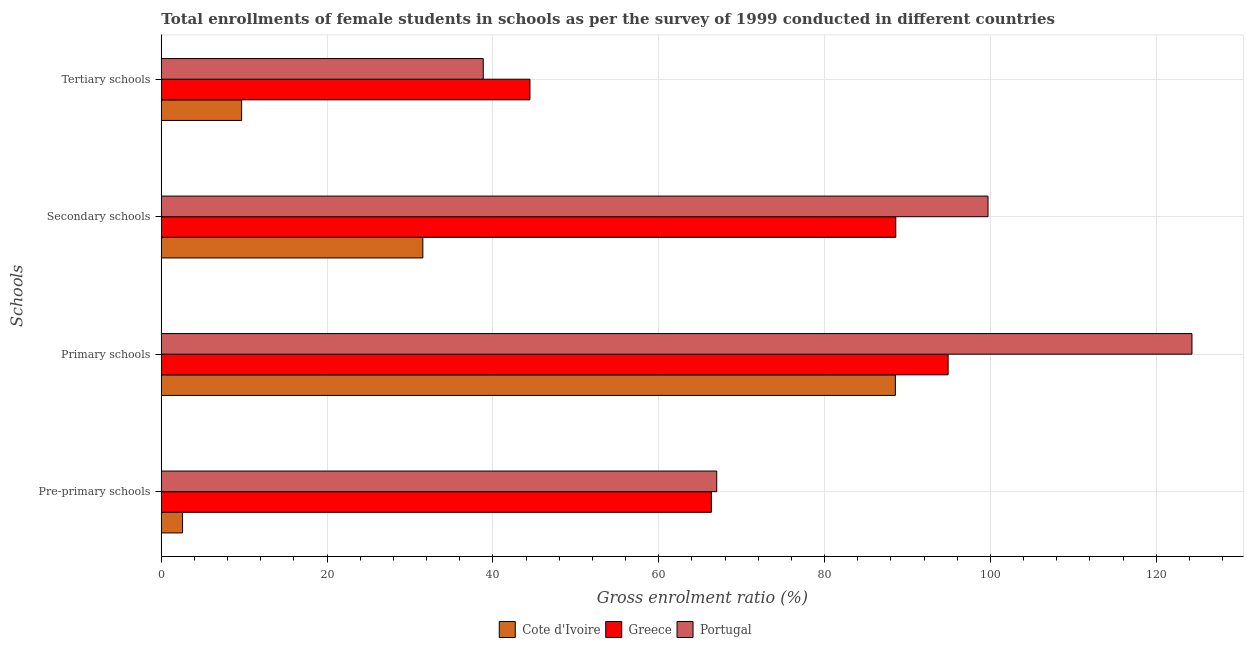How many groups of bars are there?
Your answer should be very brief. 4. Are the number of bars per tick equal to the number of legend labels?
Make the answer very short. Yes. How many bars are there on the 3rd tick from the top?
Make the answer very short. 3. What is the label of the 1st group of bars from the top?
Your response must be concise. Tertiary schools. What is the gross enrolment ratio(female) in pre-primary schools in Greece?
Your answer should be compact. 66.35. Across all countries, what is the maximum gross enrolment ratio(female) in tertiary schools?
Make the answer very short. 44.46. Across all countries, what is the minimum gross enrolment ratio(female) in primary schools?
Give a very brief answer. 88.54. In which country was the gross enrolment ratio(female) in pre-primary schools minimum?
Offer a terse response. Cote d'Ivoire. What is the total gross enrolment ratio(female) in tertiary schools in the graph?
Provide a succinct answer. 92.98. What is the difference between the gross enrolment ratio(female) in secondary schools in Portugal and that in Greece?
Your response must be concise. 11.12. What is the difference between the gross enrolment ratio(female) in pre-primary schools in Portugal and the gross enrolment ratio(female) in tertiary schools in Greece?
Give a very brief answer. 22.53. What is the average gross enrolment ratio(female) in tertiary schools per country?
Offer a very short reply. 30.99. What is the difference between the gross enrolment ratio(female) in pre-primary schools and gross enrolment ratio(female) in secondary schools in Portugal?
Keep it short and to the point. -32.72. What is the ratio of the gross enrolment ratio(female) in tertiary schools in Portugal to that in Cote d'Ivoire?
Make the answer very short. 4.01. What is the difference between the highest and the second highest gross enrolment ratio(female) in primary schools?
Give a very brief answer. 29.41. What is the difference between the highest and the lowest gross enrolment ratio(female) in tertiary schools?
Provide a short and direct response. 34.78. In how many countries, is the gross enrolment ratio(female) in secondary schools greater than the average gross enrolment ratio(female) in secondary schools taken over all countries?
Offer a very short reply. 2. Is it the case that in every country, the sum of the gross enrolment ratio(female) in pre-primary schools and gross enrolment ratio(female) in tertiary schools is greater than the sum of gross enrolment ratio(female) in primary schools and gross enrolment ratio(female) in secondary schools?
Your answer should be very brief. No. What does the 2nd bar from the bottom in Tertiary schools represents?
Your answer should be very brief. Greece. Is it the case that in every country, the sum of the gross enrolment ratio(female) in pre-primary schools and gross enrolment ratio(female) in primary schools is greater than the gross enrolment ratio(female) in secondary schools?
Provide a succinct answer. Yes. How many countries are there in the graph?
Your answer should be compact. 3. What is the difference between two consecutive major ticks on the X-axis?
Provide a succinct answer. 20. Where does the legend appear in the graph?
Offer a very short reply. Bottom center. How many legend labels are there?
Keep it short and to the point. 3. How are the legend labels stacked?
Ensure brevity in your answer.  Horizontal. What is the title of the graph?
Offer a terse response. Total enrollments of female students in schools as per the survey of 1999 conducted in different countries. Does "Guinea" appear as one of the legend labels in the graph?
Provide a short and direct response. No. What is the label or title of the Y-axis?
Offer a very short reply. Schools. What is the Gross enrolment ratio (%) in Cote d'Ivoire in Pre-primary schools?
Ensure brevity in your answer.  2.56. What is the Gross enrolment ratio (%) in Greece in Pre-primary schools?
Your response must be concise. 66.35. What is the Gross enrolment ratio (%) of Portugal in Pre-primary schools?
Keep it short and to the point. 66.99. What is the Gross enrolment ratio (%) of Cote d'Ivoire in Primary schools?
Make the answer very short. 88.54. What is the Gross enrolment ratio (%) of Greece in Primary schools?
Your answer should be compact. 94.9. What is the Gross enrolment ratio (%) of Portugal in Primary schools?
Offer a very short reply. 124.32. What is the Gross enrolment ratio (%) of Cote d'Ivoire in Secondary schools?
Ensure brevity in your answer.  31.54. What is the Gross enrolment ratio (%) of Greece in Secondary schools?
Provide a succinct answer. 88.59. What is the Gross enrolment ratio (%) of Portugal in Secondary schools?
Provide a short and direct response. 99.72. What is the Gross enrolment ratio (%) in Cote d'Ivoire in Tertiary schools?
Provide a succinct answer. 9.69. What is the Gross enrolment ratio (%) of Greece in Tertiary schools?
Keep it short and to the point. 44.46. What is the Gross enrolment ratio (%) in Portugal in Tertiary schools?
Provide a short and direct response. 38.83. Across all Schools, what is the maximum Gross enrolment ratio (%) of Cote d'Ivoire?
Ensure brevity in your answer.  88.54. Across all Schools, what is the maximum Gross enrolment ratio (%) of Greece?
Your answer should be very brief. 94.9. Across all Schools, what is the maximum Gross enrolment ratio (%) of Portugal?
Make the answer very short. 124.32. Across all Schools, what is the minimum Gross enrolment ratio (%) in Cote d'Ivoire?
Provide a short and direct response. 2.56. Across all Schools, what is the minimum Gross enrolment ratio (%) in Greece?
Give a very brief answer. 44.46. Across all Schools, what is the minimum Gross enrolment ratio (%) in Portugal?
Your answer should be very brief. 38.83. What is the total Gross enrolment ratio (%) of Cote d'Ivoire in the graph?
Offer a terse response. 132.33. What is the total Gross enrolment ratio (%) of Greece in the graph?
Give a very brief answer. 294.31. What is the total Gross enrolment ratio (%) in Portugal in the graph?
Offer a very short reply. 329.86. What is the difference between the Gross enrolment ratio (%) of Cote d'Ivoire in Pre-primary schools and that in Primary schools?
Offer a terse response. -85.98. What is the difference between the Gross enrolment ratio (%) of Greece in Pre-primary schools and that in Primary schools?
Your answer should be very brief. -28.56. What is the difference between the Gross enrolment ratio (%) of Portugal in Pre-primary schools and that in Primary schools?
Provide a succinct answer. -57.32. What is the difference between the Gross enrolment ratio (%) of Cote d'Ivoire in Pre-primary schools and that in Secondary schools?
Give a very brief answer. -28.98. What is the difference between the Gross enrolment ratio (%) in Greece in Pre-primary schools and that in Secondary schools?
Offer a terse response. -22.24. What is the difference between the Gross enrolment ratio (%) in Portugal in Pre-primary schools and that in Secondary schools?
Your response must be concise. -32.72. What is the difference between the Gross enrolment ratio (%) in Cote d'Ivoire in Pre-primary schools and that in Tertiary schools?
Your response must be concise. -7.13. What is the difference between the Gross enrolment ratio (%) in Greece in Pre-primary schools and that in Tertiary schools?
Offer a terse response. 21.88. What is the difference between the Gross enrolment ratio (%) of Portugal in Pre-primary schools and that in Tertiary schools?
Your response must be concise. 28.16. What is the difference between the Gross enrolment ratio (%) of Cote d'Ivoire in Primary schools and that in Secondary schools?
Offer a terse response. 57. What is the difference between the Gross enrolment ratio (%) of Greece in Primary schools and that in Secondary schools?
Give a very brief answer. 6.31. What is the difference between the Gross enrolment ratio (%) of Portugal in Primary schools and that in Secondary schools?
Offer a terse response. 24.6. What is the difference between the Gross enrolment ratio (%) in Cote d'Ivoire in Primary schools and that in Tertiary schools?
Keep it short and to the point. 78.85. What is the difference between the Gross enrolment ratio (%) in Greece in Primary schools and that in Tertiary schools?
Provide a succinct answer. 50.44. What is the difference between the Gross enrolment ratio (%) in Portugal in Primary schools and that in Tertiary schools?
Provide a succinct answer. 85.48. What is the difference between the Gross enrolment ratio (%) of Cote d'Ivoire in Secondary schools and that in Tertiary schools?
Offer a terse response. 21.86. What is the difference between the Gross enrolment ratio (%) of Greece in Secondary schools and that in Tertiary schools?
Provide a short and direct response. 44.13. What is the difference between the Gross enrolment ratio (%) in Portugal in Secondary schools and that in Tertiary schools?
Keep it short and to the point. 60.88. What is the difference between the Gross enrolment ratio (%) of Cote d'Ivoire in Pre-primary schools and the Gross enrolment ratio (%) of Greece in Primary schools?
Keep it short and to the point. -92.34. What is the difference between the Gross enrolment ratio (%) of Cote d'Ivoire in Pre-primary schools and the Gross enrolment ratio (%) of Portugal in Primary schools?
Keep it short and to the point. -121.76. What is the difference between the Gross enrolment ratio (%) in Greece in Pre-primary schools and the Gross enrolment ratio (%) in Portugal in Primary schools?
Give a very brief answer. -57.97. What is the difference between the Gross enrolment ratio (%) of Cote d'Ivoire in Pre-primary schools and the Gross enrolment ratio (%) of Greece in Secondary schools?
Provide a succinct answer. -86.03. What is the difference between the Gross enrolment ratio (%) in Cote d'Ivoire in Pre-primary schools and the Gross enrolment ratio (%) in Portugal in Secondary schools?
Keep it short and to the point. -97.15. What is the difference between the Gross enrolment ratio (%) in Greece in Pre-primary schools and the Gross enrolment ratio (%) in Portugal in Secondary schools?
Your answer should be compact. -33.37. What is the difference between the Gross enrolment ratio (%) in Cote d'Ivoire in Pre-primary schools and the Gross enrolment ratio (%) in Greece in Tertiary schools?
Give a very brief answer. -41.9. What is the difference between the Gross enrolment ratio (%) of Cote d'Ivoire in Pre-primary schools and the Gross enrolment ratio (%) of Portugal in Tertiary schools?
Provide a short and direct response. -36.27. What is the difference between the Gross enrolment ratio (%) in Greece in Pre-primary schools and the Gross enrolment ratio (%) in Portugal in Tertiary schools?
Give a very brief answer. 27.51. What is the difference between the Gross enrolment ratio (%) in Cote d'Ivoire in Primary schools and the Gross enrolment ratio (%) in Greece in Secondary schools?
Your answer should be compact. -0.05. What is the difference between the Gross enrolment ratio (%) in Cote d'Ivoire in Primary schools and the Gross enrolment ratio (%) in Portugal in Secondary schools?
Provide a short and direct response. -11.17. What is the difference between the Gross enrolment ratio (%) of Greece in Primary schools and the Gross enrolment ratio (%) of Portugal in Secondary schools?
Your response must be concise. -4.81. What is the difference between the Gross enrolment ratio (%) in Cote d'Ivoire in Primary schools and the Gross enrolment ratio (%) in Greece in Tertiary schools?
Provide a short and direct response. 44.08. What is the difference between the Gross enrolment ratio (%) of Cote d'Ivoire in Primary schools and the Gross enrolment ratio (%) of Portugal in Tertiary schools?
Your response must be concise. 49.71. What is the difference between the Gross enrolment ratio (%) of Greece in Primary schools and the Gross enrolment ratio (%) of Portugal in Tertiary schools?
Your response must be concise. 56.07. What is the difference between the Gross enrolment ratio (%) of Cote d'Ivoire in Secondary schools and the Gross enrolment ratio (%) of Greece in Tertiary schools?
Your response must be concise. -12.92. What is the difference between the Gross enrolment ratio (%) of Cote d'Ivoire in Secondary schools and the Gross enrolment ratio (%) of Portugal in Tertiary schools?
Give a very brief answer. -7.29. What is the difference between the Gross enrolment ratio (%) in Greece in Secondary schools and the Gross enrolment ratio (%) in Portugal in Tertiary schools?
Offer a terse response. 49.76. What is the average Gross enrolment ratio (%) of Cote d'Ivoire per Schools?
Provide a succinct answer. 33.08. What is the average Gross enrolment ratio (%) of Greece per Schools?
Your answer should be compact. 73.58. What is the average Gross enrolment ratio (%) of Portugal per Schools?
Make the answer very short. 82.46. What is the difference between the Gross enrolment ratio (%) of Cote d'Ivoire and Gross enrolment ratio (%) of Greece in Pre-primary schools?
Provide a succinct answer. -63.79. What is the difference between the Gross enrolment ratio (%) of Cote d'Ivoire and Gross enrolment ratio (%) of Portugal in Pre-primary schools?
Your response must be concise. -64.43. What is the difference between the Gross enrolment ratio (%) of Greece and Gross enrolment ratio (%) of Portugal in Pre-primary schools?
Offer a terse response. -0.65. What is the difference between the Gross enrolment ratio (%) of Cote d'Ivoire and Gross enrolment ratio (%) of Greece in Primary schools?
Your answer should be very brief. -6.36. What is the difference between the Gross enrolment ratio (%) in Cote d'Ivoire and Gross enrolment ratio (%) in Portugal in Primary schools?
Offer a very short reply. -35.77. What is the difference between the Gross enrolment ratio (%) of Greece and Gross enrolment ratio (%) of Portugal in Primary schools?
Give a very brief answer. -29.41. What is the difference between the Gross enrolment ratio (%) in Cote d'Ivoire and Gross enrolment ratio (%) in Greece in Secondary schools?
Your response must be concise. -57.05. What is the difference between the Gross enrolment ratio (%) of Cote d'Ivoire and Gross enrolment ratio (%) of Portugal in Secondary schools?
Offer a very short reply. -68.17. What is the difference between the Gross enrolment ratio (%) of Greece and Gross enrolment ratio (%) of Portugal in Secondary schools?
Offer a very short reply. -11.12. What is the difference between the Gross enrolment ratio (%) of Cote d'Ivoire and Gross enrolment ratio (%) of Greece in Tertiary schools?
Keep it short and to the point. -34.78. What is the difference between the Gross enrolment ratio (%) in Cote d'Ivoire and Gross enrolment ratio (%) in Portugal in Tertiary schools?
Provide a succinct answer. -29.15. What is the difference between the Gross enrolment ratio (%) of Greece and Gross enrolment ratio (%) of Portugal in Tertiary schools?
Provide a succinct answer. 5.63. What is the ratio of the Gross enrolment ratio (%) of Cote d'Ivoire in Pre-primary schools to that in Primary schools?
Ensure brevity in your answer.  0.03. What is the ratio of the Gross enrolment ratio (%) in Greece in Pre-primary schools to that in Primary schools?
Ensure brevity in your answer.  0.7. What is the ratio of the Gross enrolment ratio (%) in Portugal in Pre-primary schools to that in Primary schools?
Offer a terse response. 0.54. What is the ratio of the Gross enrolment ratio (%) of Cote d'Ivoire in Pre-primary schools to that in Secondary schools?
Your answer should be compact. 0.08. What is the ratio of the Gross enrolment ratio (%) of Greece in Pre-primary schools to that in Secondary schools?
Offer a very short reply. 0.75. What is the ratio of the Gross enrolment ratio (%) of Portugal in Pre-primary schools to that in Secondary schools?
Offer a very short reply. 0.67. What is the ratio of the Gross enrolment ratio (%) in Cote d'Ivoire in Pre-primary schools to that in Tertiary schools?
Offer a very short reply. 0.26. What is the ratio of the Gross enrolment ratio (%) in Greece in Pre-primary schools to that in Tertiary schools?
Provide a succinct answer. 1.49. What is the ratio of the Gross enrolment ratio (%) in Portugal in Pre-primary schools to that in Tertiary schools?
Provide a succinct answer. 1.73. What is the ratio of the Gross enrolment ratio (%) in Cote d'Ivoire in Primary schools to that in Secondary schools?
Give a very brief answer. 2.81. What is the ratio of the Gross enrolment ratio (%) of Greece in Primary schools to that in Secondary schools?
Make the answer very short. 1.07. What is the ratio of the Gross enrolment ratio (%) in Portugal in Primary schools to that in Secondary schools?
Give a very brief answer. 1.25. What is the ratio of the Gross enrolment ratio (%) in Cote d'Ivoire in Primary schools to that in Tertiary schools?
Offer a very short reply. 9.14. What is the ratio of the Gross enrolment ratio (%) in Greece in Primary schools to that in Tertiary schools?
Give a very brief answer. 2.13. What is the ratio of the Gross enrolment ratio (%) in Portugal in Primary schools to that in Tertiary schools?
Offer a terse response. 3.2. What is the ratio of the Gross enrolment ratio (%) of Cote d'Ivoire in Secondary schools to that in Tertiary schools?
Offer a terse response. 3.26. What is the ratio of the Gross enrolment ratio (%) of Greece in Secondary schools to that in Tertiary schools?
Offer a terse response. 1.99. What is the ratio of the Gross enrolment ratio (%) in Portugal in Secondary schools to that in Tertiary schools?
Give a very brief answer. 2.57. What is the difference between the highest and the second highest Gross enrolment ratio (%) in Cote d'Ivoire?
Offer a very short reply. 57. What is the difference between the highest and the second highest Gross enrolment ratio (%) of Greece?
Your answer should be very brief. 6.31. What is the difference between the highest and the second highest Gross enrolment ratio (%) of Portugal?
Offer a very short reply. 24.6. What is the difference between the highest and the lowest Gross enrolment ratio (%) in Cote d'Ivoire?
Offer a terse response. 85.98. What is the difference between the highest and the lowest Gross enrolment ratio (%) in Greece?
Your answer should be compact. 50.44. What is the difference between the highest and the lowest Gross enrolment ratio (%) of Portugal?
Give a very brief answer. 85.48. 